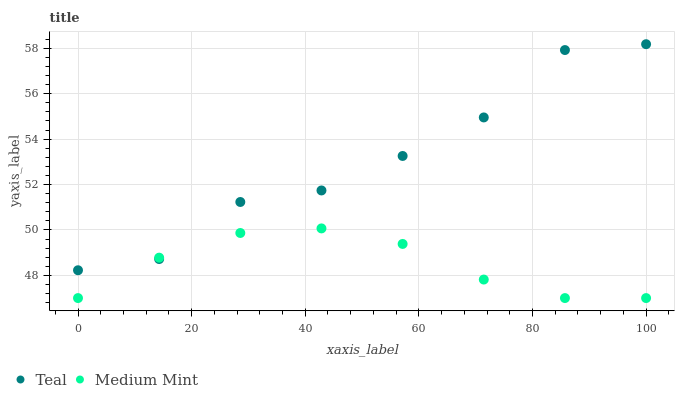Does Medium Mint have the minimum area under the curve?
Answer yes or no. Yes. Does Teal have the maximum area under the curve?
Answer yes or no. Yes. Does Teal have the minimum area under the curve?
Answer yes or no. No. Is Medium Mint the smoothest?
Answer yes or no. Yes. Is Teal the roughest?
Answer yes or no. Yes. Is Teal the smoothest?
Answer yes or no. No. Does Medium Mint have the lowest value?
Answer yes or no. Yes. Does Teal have the lowest value?
Answer yes or no. No. Does Teal have the highest value?
Answer yes or no. Yes. Does Teal intersect Medium Mint?
Answer yes or no. Yes. Is Teal less than Medium Mint?
Answer yes or no. No. Is Teal greater than Medium Mint?
Answer yes or no. No. 